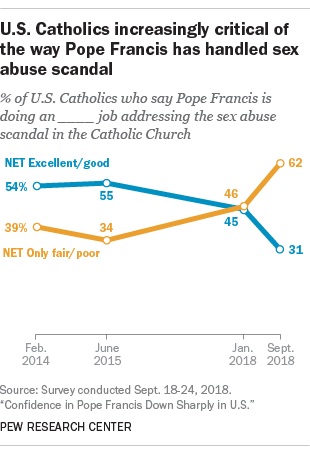Outline some significant characteristics in this image. The difference between the blue and orange graphs is lowest in the January 2018 time period. The color of the graph with the lowest value of 31 is blue. 